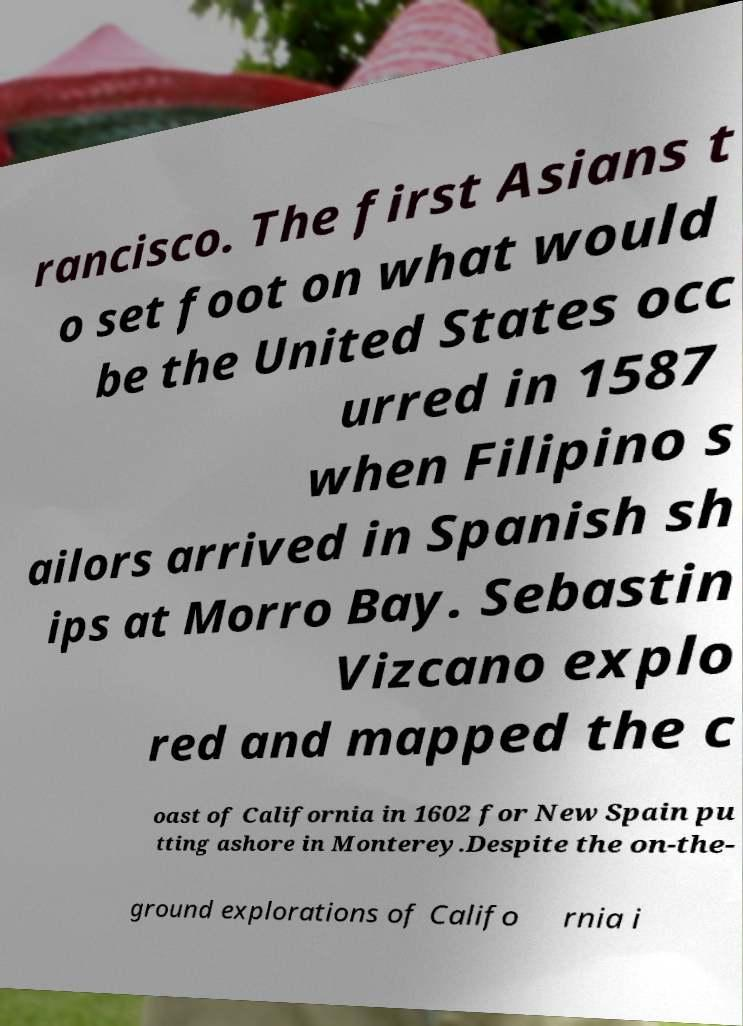Can you read and provide the text displayed in the image?This photo seems to have some interesting text. Can you extract and type it out for me? rancisco. The first Asians t o set foot on what would be the United States occ urred in 1587 when Filipino s ailors arrived in Spanish sh ips at Morro Bay. Sebastin Vizcano explo red and mapped the c oast of California in 1602 for New Spain pu tting ashore in Monterey.Despite the on-the- ground explorations of Califo rnia i 